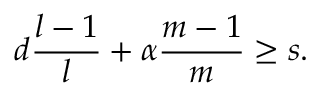Convert formula to latex. <formula><loc_0><loc_0><loc_500><loc_500>d \frac { l - 1 } { l } + \alpha \frac { m - 1 } { m } \geq s .</formula> 